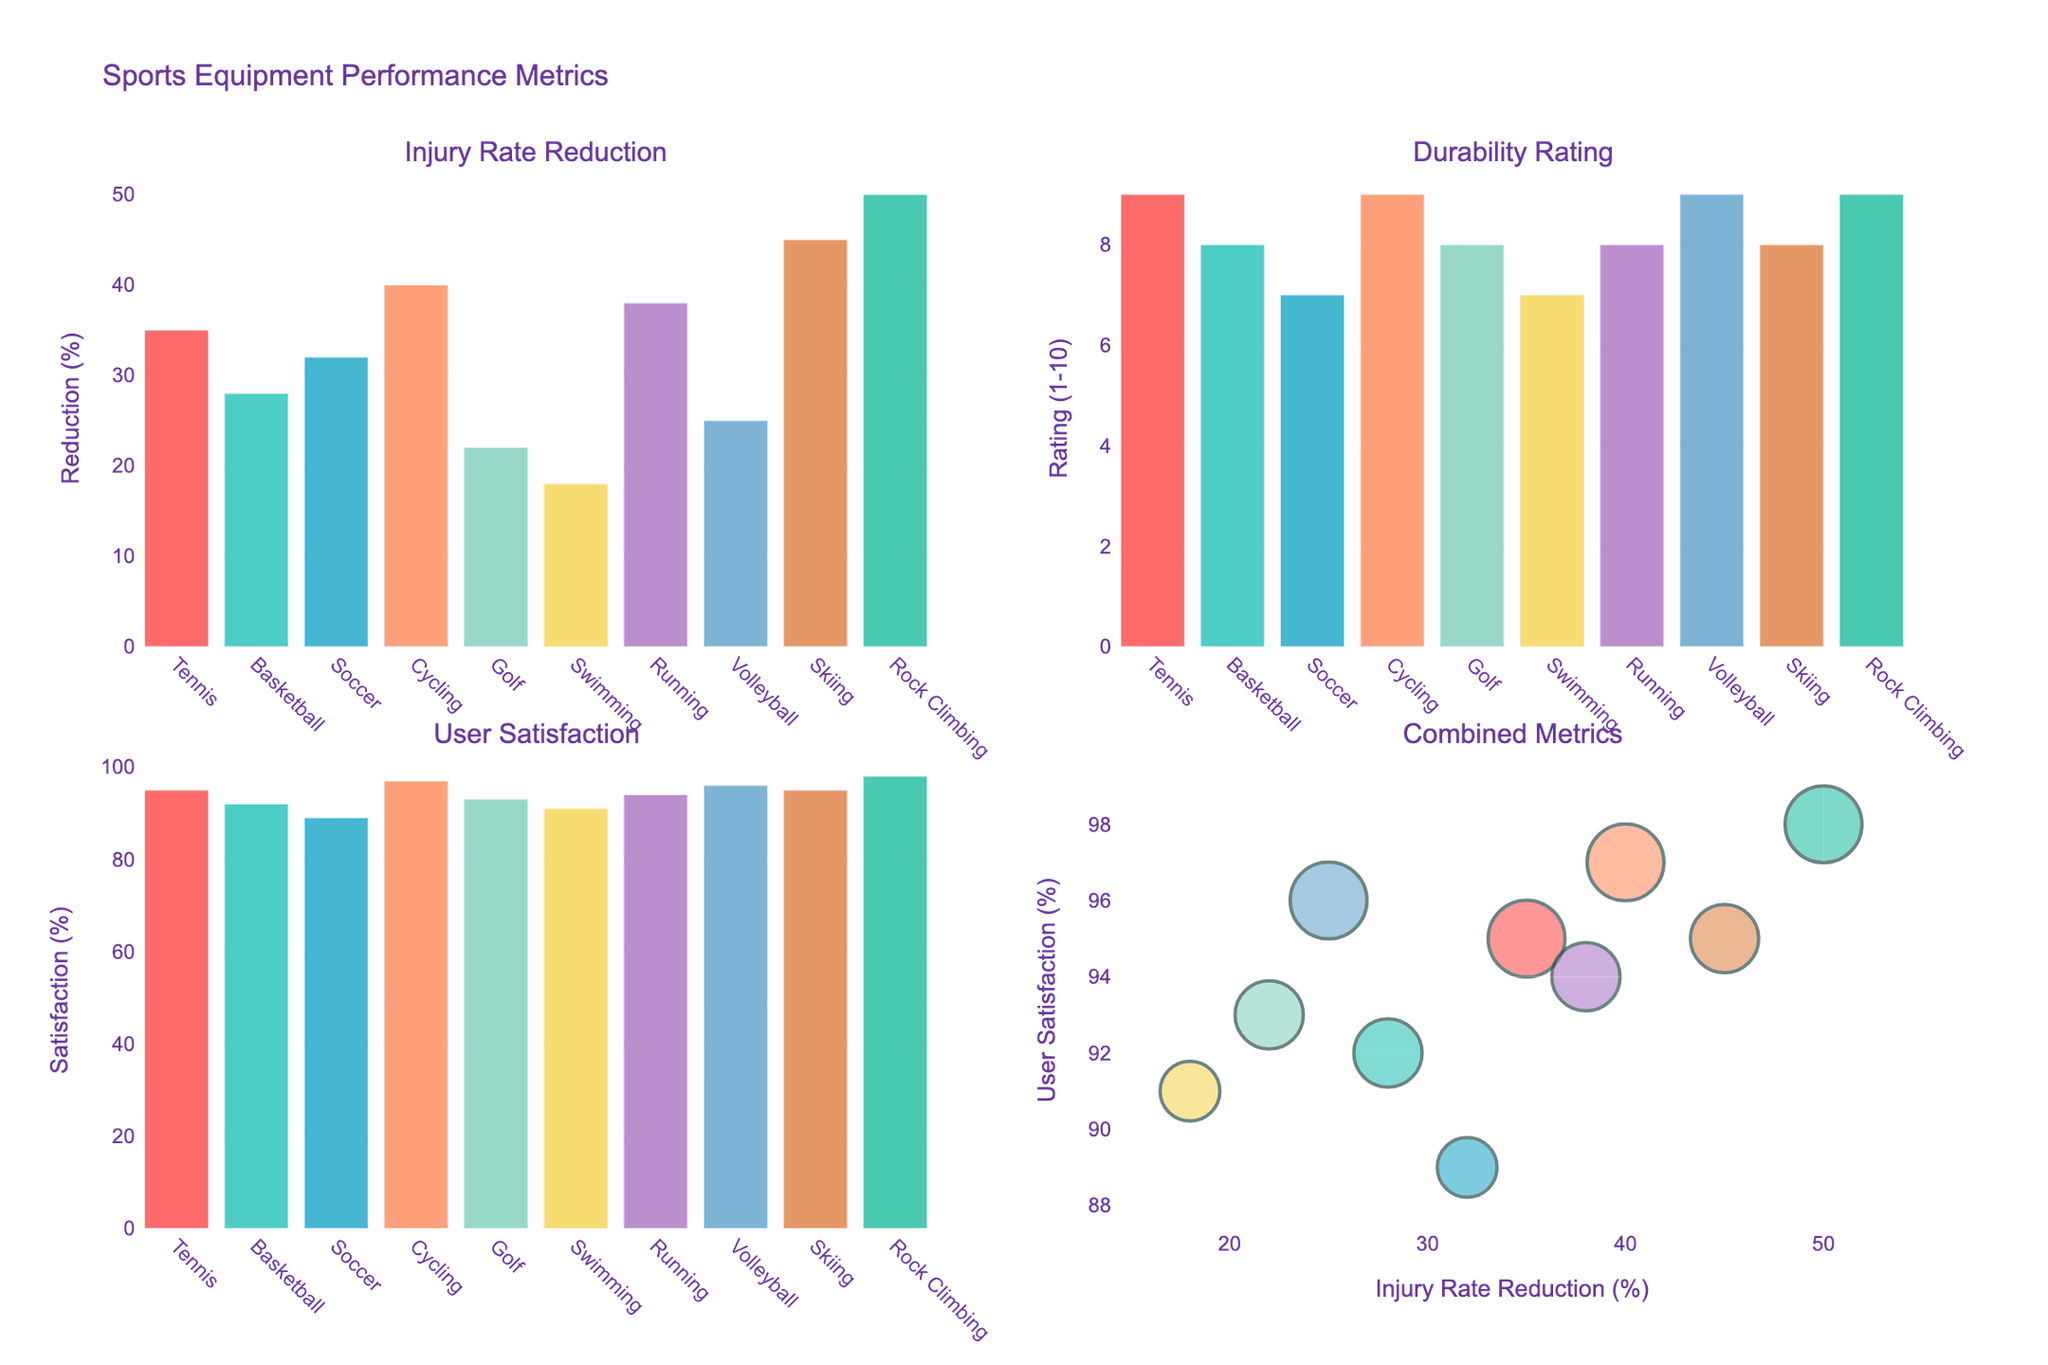What's the title of the figure? The title is typically displayed prominently above the rest of the figure. In this case, it is located at the top center of the figure.
Answer: Distribution of Historical Artifacts in Syria How many historical time periods are included in the figure? You can count the number of distinct time periods listed on the x-axis. Each subplot shows distinct periods, which in total includes Paleolithic, Neolithic, Bronze Age, Iron Age, Hellenistic, Roman, Byzantine, Islamic, Crusader, and Ottoman.
Answer: 10 Which region has the highest number of artifacts in the Islamic period? Look at the bars corresponding to the Islamic period across all four subplots and compare their heights. Northern Syria has a bar height of 50, which is the highest.
Answer: Northern Syria What is the sum of artifacts found in Central Syria during the Roman and Byzantine periods? Locate the Roman and Byzantine periods in the Central Syria subplot and add the numbers: 42 (Roman) + 28 (Byzantine)
Answer: 70 Are there more artifacts in Southern Syria during the Crusader period compared to Coastal Syria during the same period? Compare the heights of the bars for the Crusader period in both the Southern Syria and Coastal Syria subplots. Southern Syria has 10 artifacts, while Coastal Syria has 8 artifacts.
Answer: Yes Which region shows the greatest increase in artifacts from the Bronze Age to the Iron Age? Calculate the difference in the number of artifacts between the Iron Age and Bronze Age for each region, then compare the differences to identify the largest increase. 
Northern Syria: 40 - 35 = 5
Central Syria: 38 - 30 = 8
Southern Syria: 32 - 28 = 4
Coastal Syria: 30 - 25 = 5
Answer: Central Syria What is the average number of artifacts found in Coastal Syria during any given period? Add the number of artifacts across all periods in the Coastal Syria subplot and then divide by the number of periods: (6+10+25+30+18+35+22+40+8+18) / 10
Answer: 21.2 In which time period did Northern Syria have the least number of artifacts? Identify the shortest bar in the Northern Syria subplot, which corresponds to the Paleolithic period.
Answer: Paleolithic How does the artifact distribution in Coastal Syria during the Hellenistic period compare to the Byzantine period? Compare the bar heights for the Hellenistic and Byzantine periods in the Coastal Syria subplot. Hellenistic has 18 artifacts, while Byzantine has 22 artifacts.
Answer: Coastal Syria has more artifacts in the Byzantine period Which region consistently has the highest number of artifacts across all periods? Examine each period's subplot and identify which region frequently has the tallest bar. Northern Syria frequently has the highest number of artifacts across various periods.
Answer: Northern Syria 